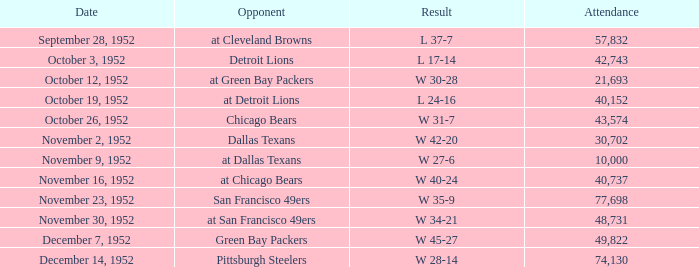When is the last week that has a result of a w 34-21? 10.0. 